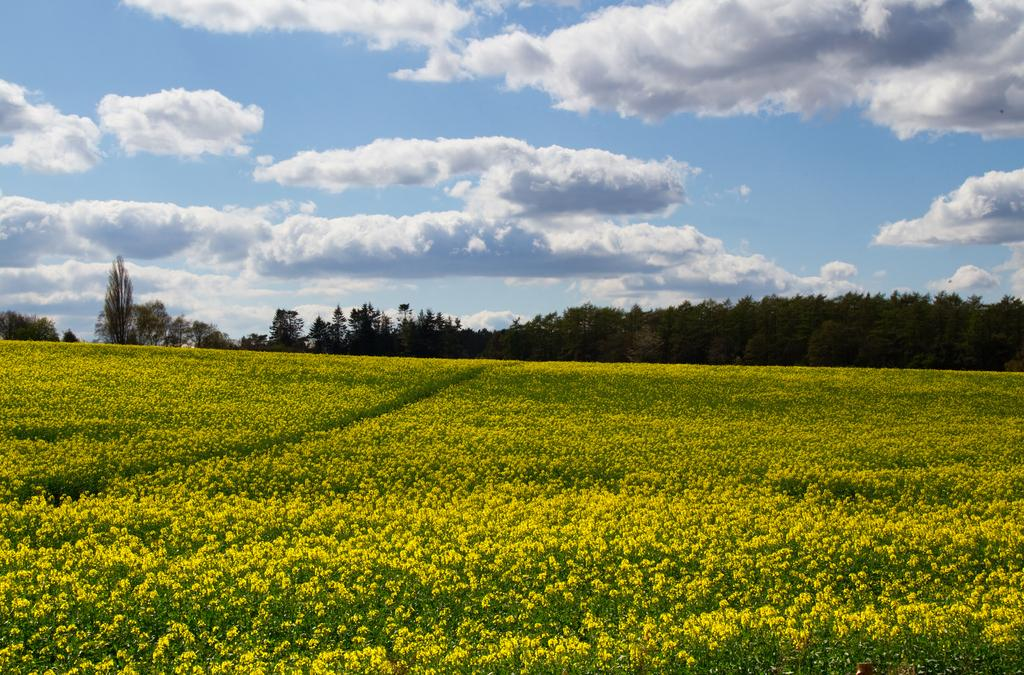What is the main subject of the image? There are many flowers in the middle of the image. What can be seen in the background of the image? There are trees in the background of the image. What is visible at the top of the image? The sky is visible at the top of the image. How many rings can be seen on the flowers in the image? There are no rings present on the flowers in the image. What type of pencil is being used to draw the flowers in the image? There is no pencil or drawing activity depicted in the image; it features real flowers. 